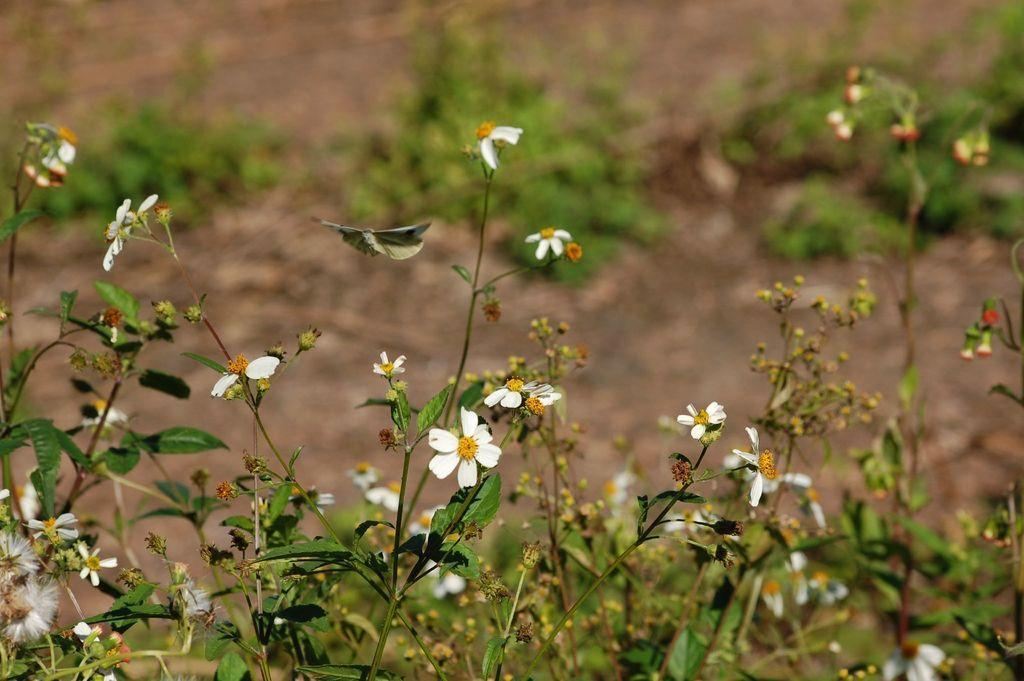What type of plants can be seen in the image? There are plants with small white flowers in the image. What can be seen in the background of the image? There is soil visible in the background of the image. Are there any other plants present in the image? Yes, there are additional plants growing in the soil in the background. What time does the clock show in the image? There is no clock present in the image, so it is not possible to determine the time. 